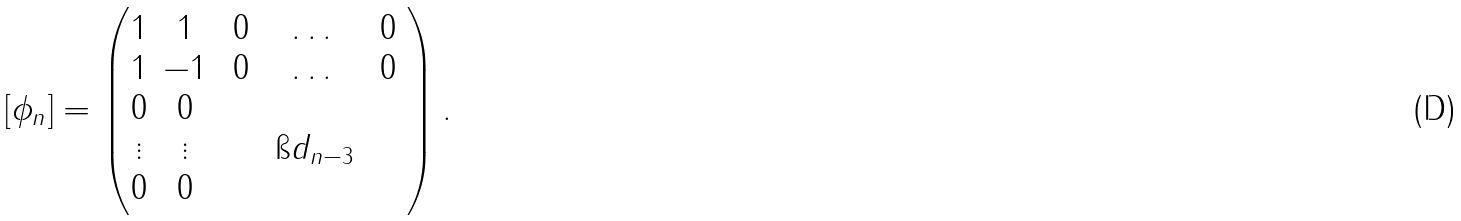<formula> <loc_0><loc_0><loc_500><loc_500>[ \phi _ { n } ] = \left ( \begin{matrix} 1 & 1 & 0 & \dots & 0 \\ 1 & - 1 & 0 & \dots & 0 \\ 0 & 0 & \quad & \quad & \quad \\ \vdots & \vdots & \quad & \i d _ { n - 3 } & \quad \\ 0 & 0 & \quad & \quad & \quad \\ \end{matrix} \right ) .</formula> 